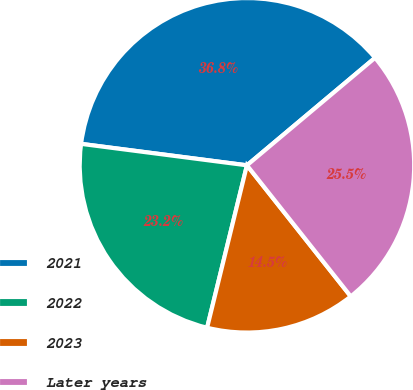Convert chart. <chart><loc_0><loc_0><loc_500><loc_500><pie_chart><fcel>2021<fcel>2022<fcel>2023<fcel>Later years<nl><fcel>36.84%<fcel>23.22%<fcel>14.49%<fcel>25.45%<nl></chart> 